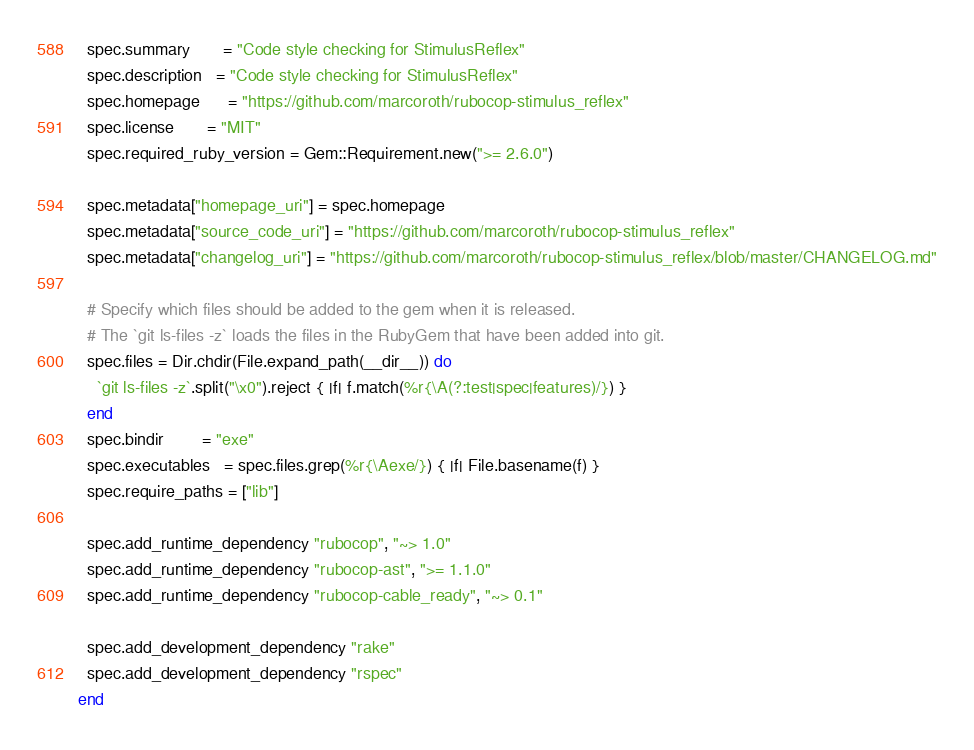Convert code to text. <code><loc_0><loc_0><loc_500><loc_500><_Ruby_>  spec.summary       = "Code style checking for StimulusReflex"
  spec.description   = "Code style checking for StimulusReflex"
  spec.homepage      = "https://github.com/marcoroth/rubocop-stimulus_reflex"
  spec.license       = "MIT"
  spec.required_ruby_version = Gem::Requirement.new(">= 2.6.0")

  spec.metadata["homepage_uri"] = spec.homepage
  spec.metadata["source_code_uri"] = "https://github.com/marcoroth/rubocop-stimulus_reflex"
  spec.metadata["changelog_uri"] = "https://github.com/marcoroth/rubocop-stimulus_reflex/blob/master/CHANGELOG.md"

  # Specify which files should be added to the gem when it is released.
  # The `git ls-files -z` loads the files in the RubyGem that have been added into git.
  spec.files = Dir.chdir(File.expand_path(__dir__)) do
    `git ls-files -z`.split("\x0").reject { |f| f.match(%r{\A(?:test|spec|features)/}) }
  end
  spec.bindir        = "exe"
  spec.executables   = spec.files.grep(%r{\Aexe/}) { |f| File.basename(f) }
  spec.require_paths = ["lib"]

  spec.add_runtime_dependency "rubocop", "~> 1.0"
  spec.add_runtime_dependency "rubocop-ast", ">= 1.1.0"
  spec.add_runtime_dependency "rubocop-cable_ready", "~> 0.1"

  spec.add_development_dependency "rake"
  spec.add_development_dependency "rspec"
end
</code> 